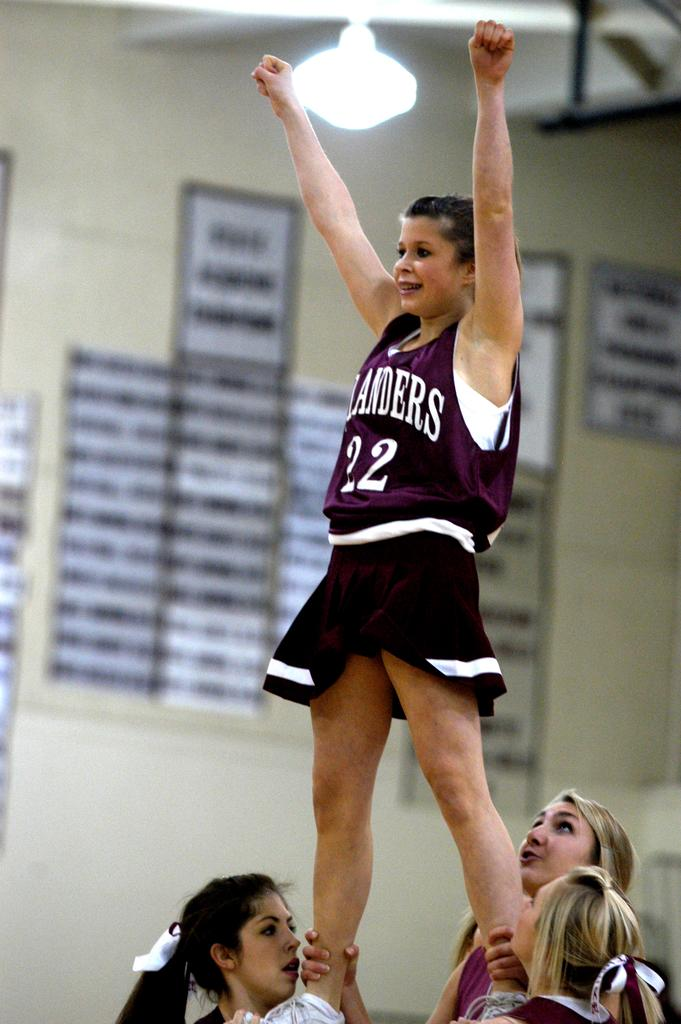Provide a one-sentence caption for the provided image. A cheerleader wearing jersey number 22 is lifted by other cheerleaders. 